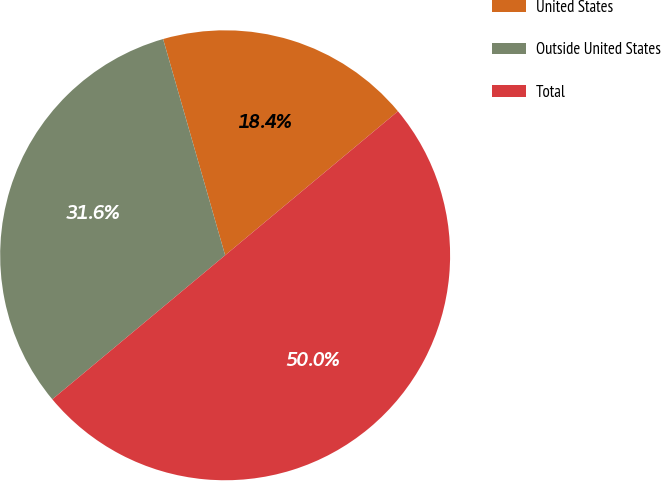Convert chart to OTSL. <chart><loc_0><loc_0><loc_500><loc_500><pie_chart><fcel>United States<fcel>Outside United States<fcel>Total<nl><fcel>18.39%<fcel>31.61%<fcel>50.0%<nl></chart> 